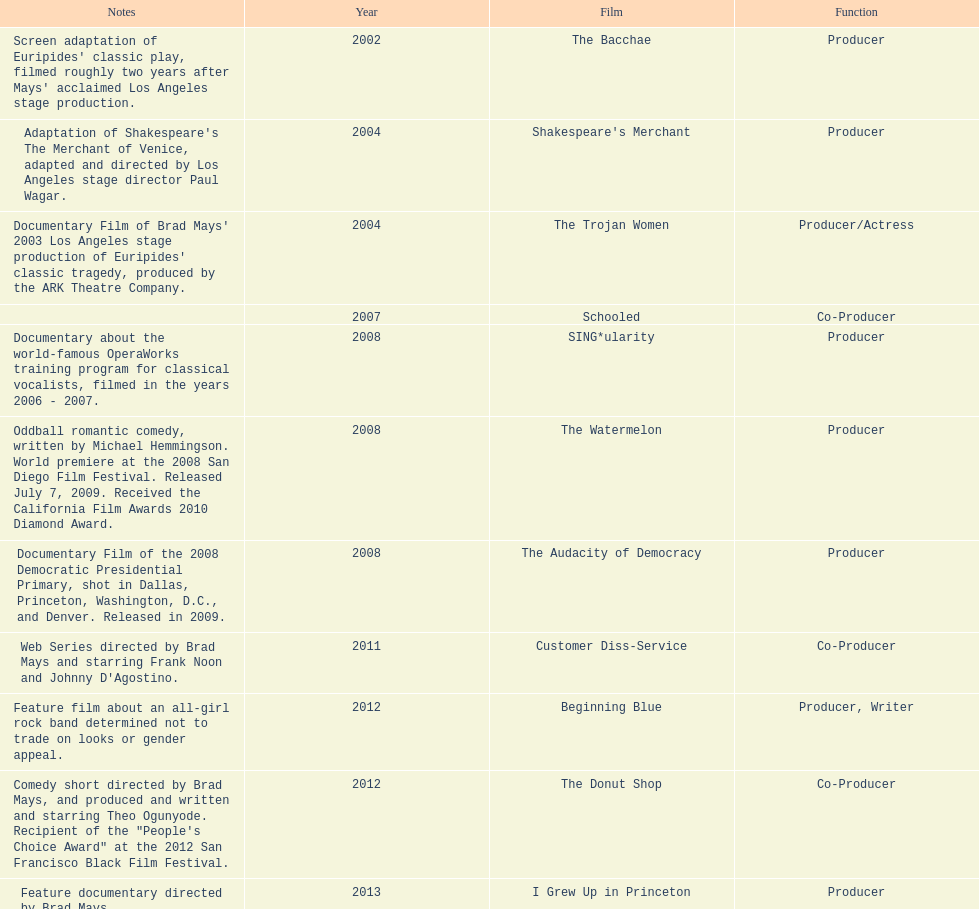Which film was before the audacity of democracy? The Watermelon. 